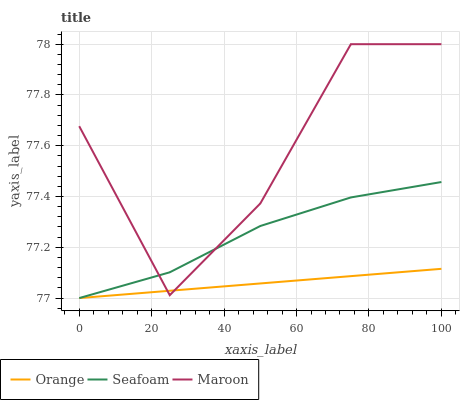Does Orange have the minimum area under the curve?
Answer yes or no. Yes. Does Maroon have the maximum area under the curve?
Answer yes or no. Yes. Does Seafoam have the minimum area under the curve?
Answer yes or no. No. Does Seafoam have the maximum area under the curve?
Answer yes or no. No. Is Orange the smoothest?
Answer yes or no. Yes. Is Maroon the roughest?
Answer yes or no. Yes. Is Seafoam the smoothest?
Answer yes or no. No. Is Seafoam the roughest?
Answer yes or no. No. Does Maroon have the lowest value?
Answer yes or no. No. Does Maroon have the highest value?
Answer yes or no. Yes. Does Seafoam have the highest value?
Answer yes or no. No. Does Maroon intersect Seafoam?
Answer yes or no. Yes. Is Maroon less than Seafoam?
Answer yes or no. No. Is Maroon greater than Seafoam?
Answer yes or no. No. 